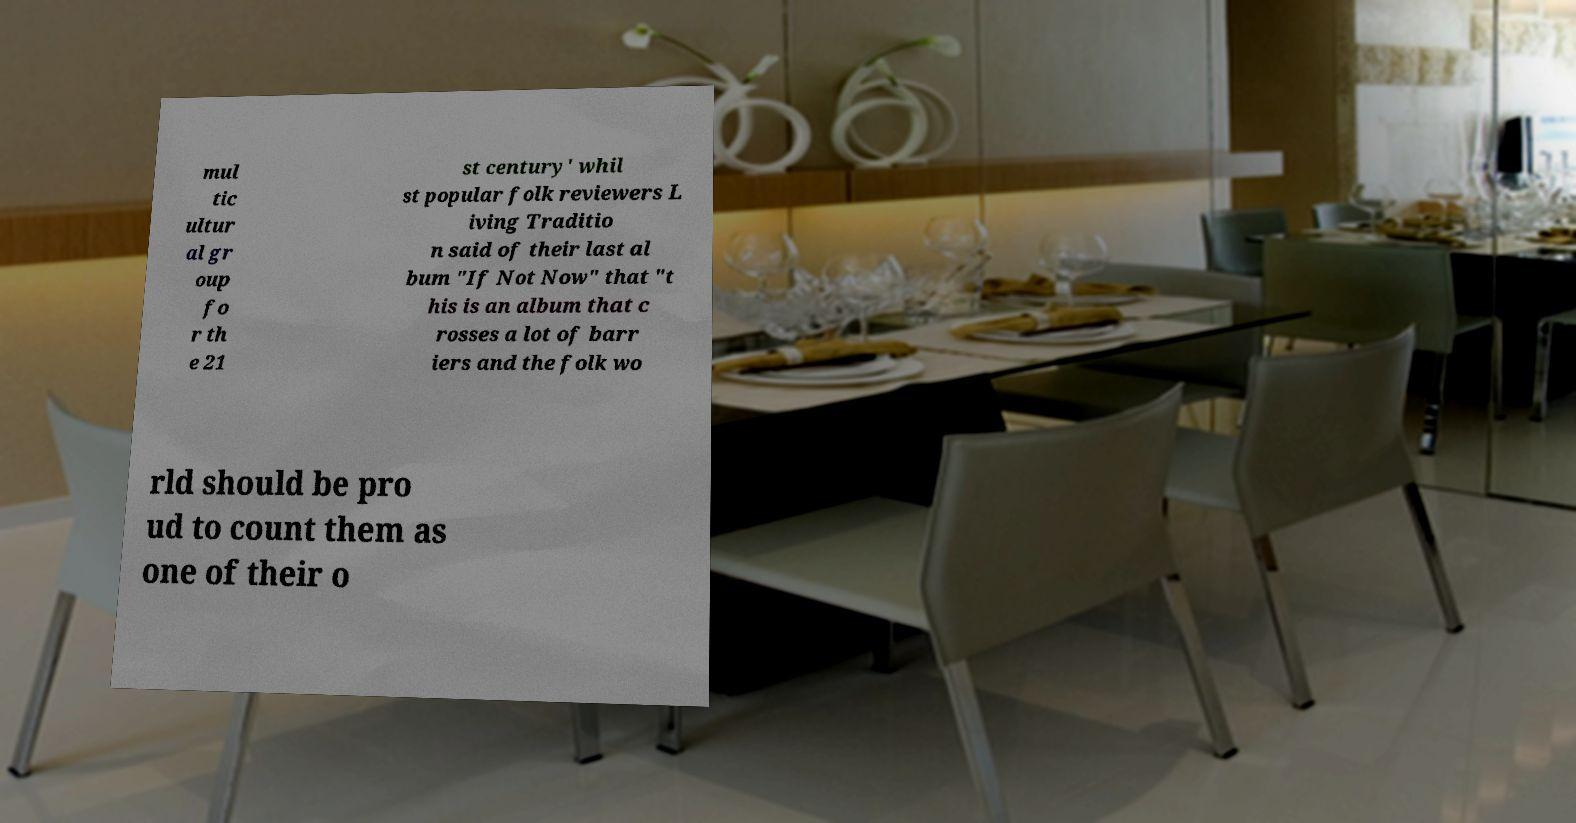Please read and relay the text visible in this image. What does it say? mul tic ultur al gr oup fo r th e 21 st century' whil st popular folk reviewers L iving Traditio n said of their last al bum "If Not Now" that "t his is an album that c rosses a lot of barr iers and the folk wo rld should be pro ud to count them as one of their o 